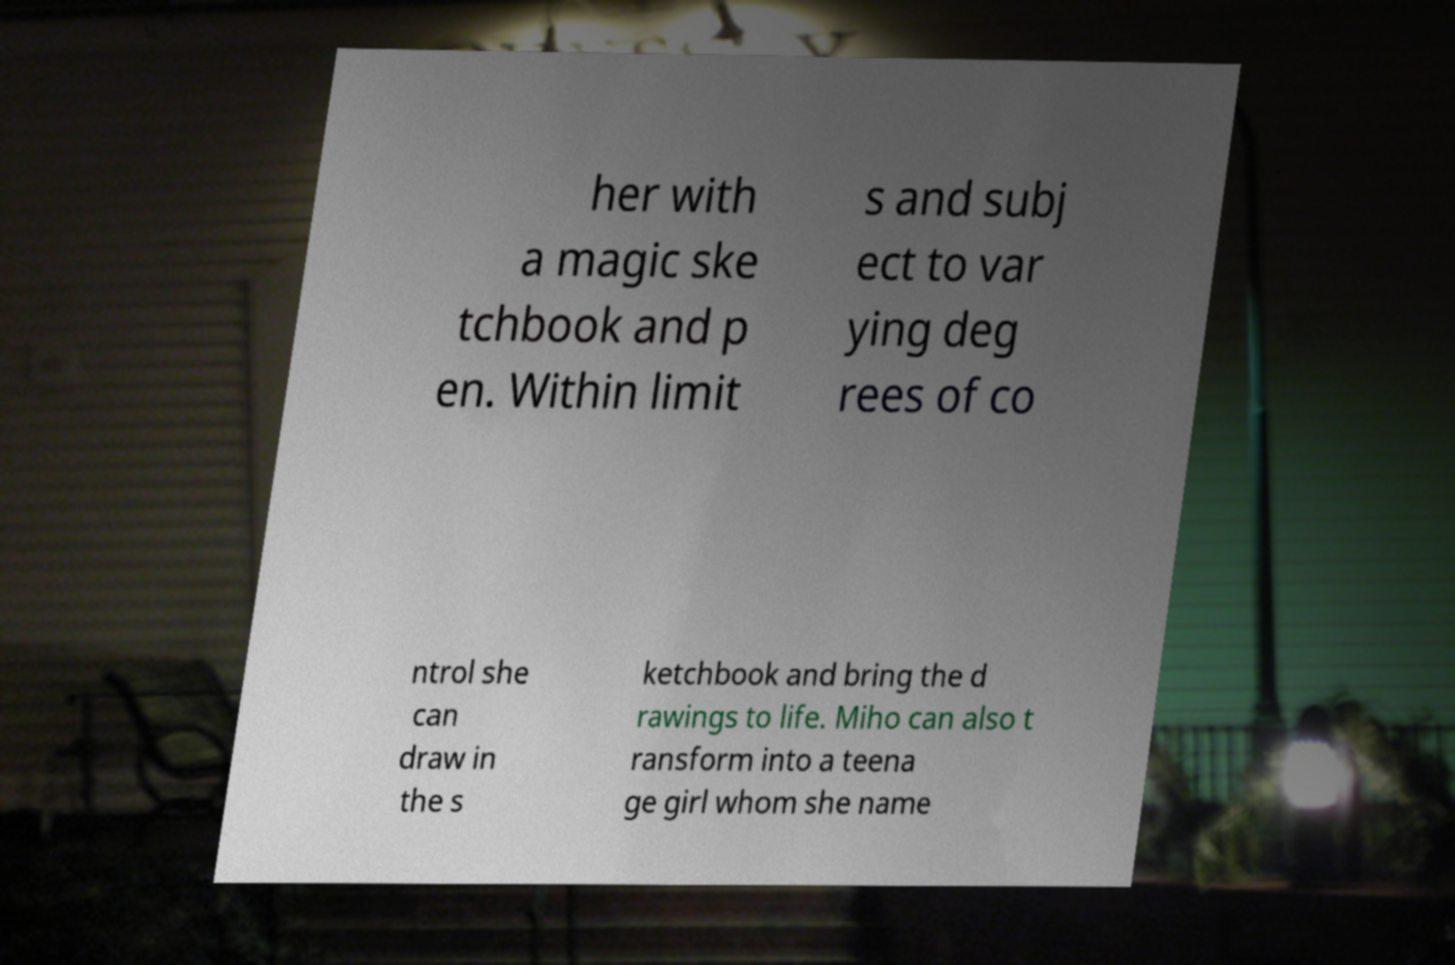Please read and relay the text visible in this image. What does it say? her with a magic ske tchbook and p en. Within limit s and subj ect to var ying deg rees of co ntrol she can draw in the s ketchbook and bring the d rawings to life. Miho can also t ransform into a teena ge girl whom she name 